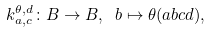Convert formula to latex. <formula><loc_0><loc_0><loc_500><loc_500>k ^ { \theta , d } _ { a , c } \colon B \to B , \ b \mapsto \theta ( a b c d ) ,</formula> 